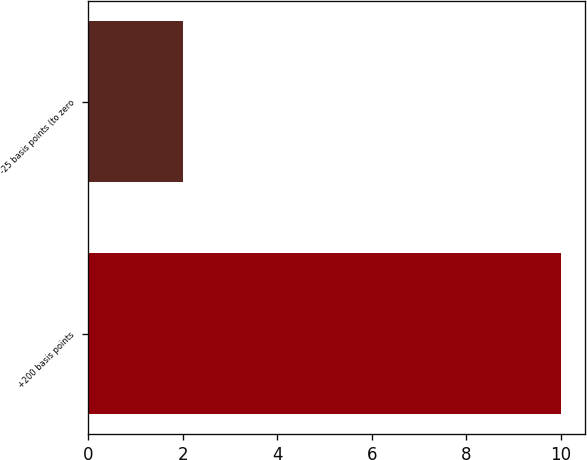Convert chart. <chart><loc_0><loc_0><loc_500><loc_500><bar_chart><fcel>+200 basis points<fcel>-25 basis points (to zero<nl><fcel>10<fcel>2<nl></chart> 